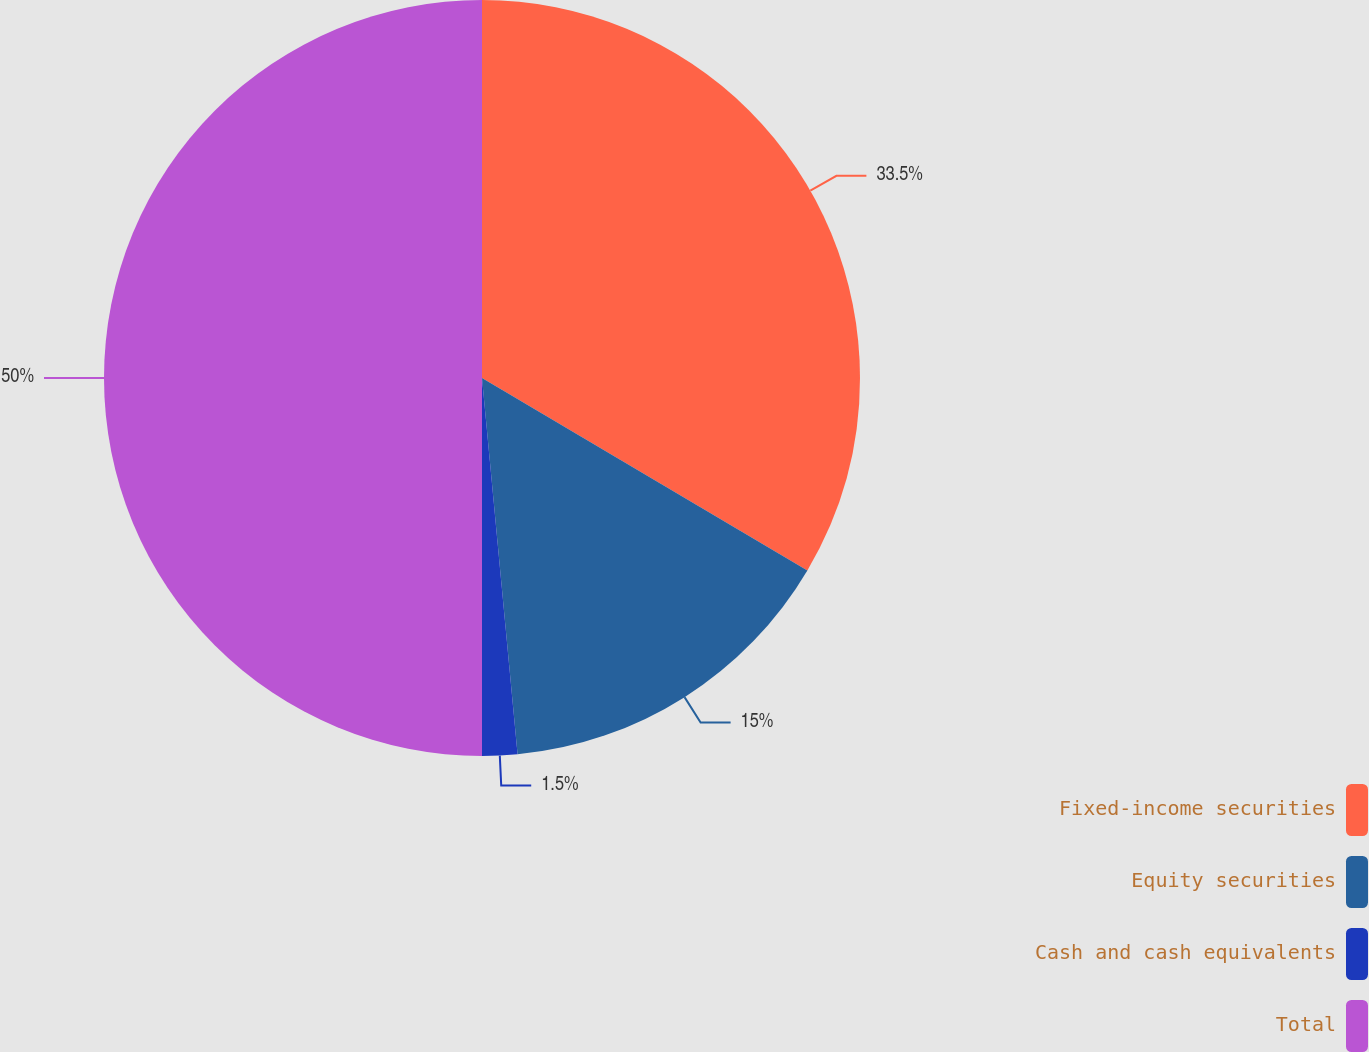<chart> <loc_0><loc_0><loc_500><loc_500><pie_chart><fcel>Fixed-income securities<fcel>Equity securities<fcel>Cash and cash equivalents<fcel>Total<nl><fcel>33.5%<fcel>15.0%<fcel>1.5%<fcel>50.0%<nl></chart> 